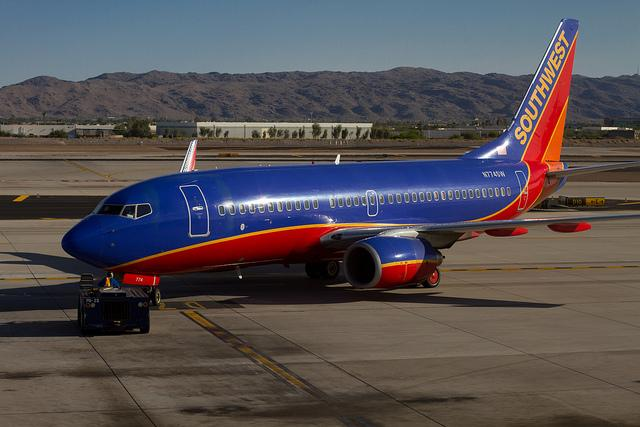Where is the plane stopped? runway 